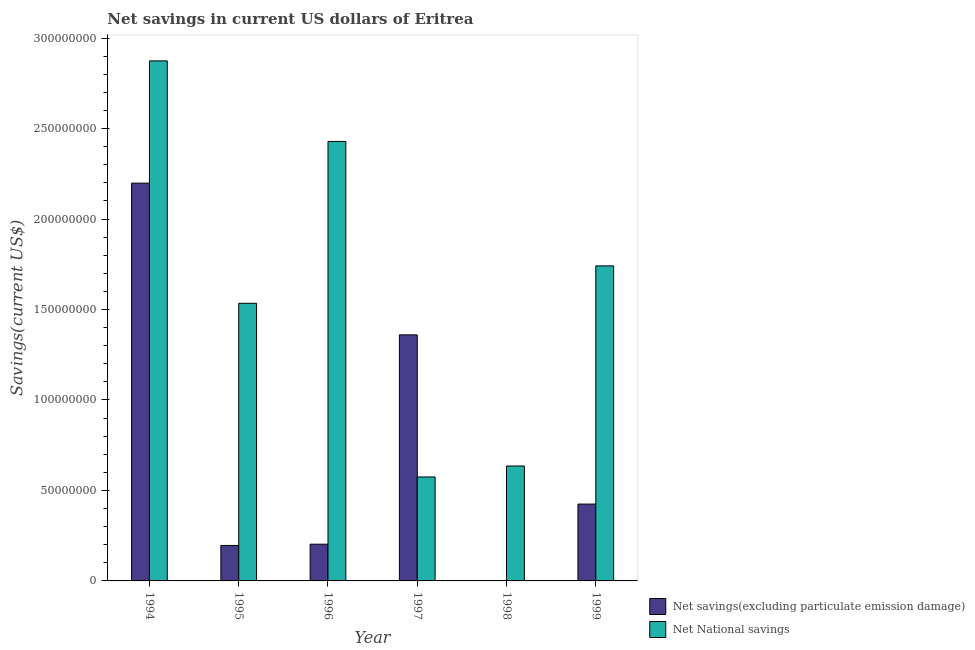How many different coloured bars are there?
Make the answer very short. 2. Are the number of bars per tick equal to the number of legend labels?
Offer a very short reply. No. How many bars are there on the 1st tick from the right?
Offer a very short reply. 2. In how many cases, is the number of bars for a given year not equal to the number of legend labels?
Make the answer very short. 1. What is the net national savings in 1994?
Offer a terse response. 2.87e+08. Across all years, what is the maximum net national savings?
Your answer should be very brief. 2.87e+08. In which year was the net savings(excluding particulate emission damage) maximum?
Your answer should be very brief. 1994. What is the total net national savings in the graph?
Make the answer very short. 9.79e+08. What is the difference between the net national savings in 1996 and that in 1997?
Make the answer very short. 1.85e+08. What is the difference between the net savings(excluding particulate emission damage) in 1997 and the net national savings in 1998?
Provide a short and direct response. 1.36e+08. What is the average net savings(excluding particulate emission damage) per year?
Ensure brevity in your answer.  7.30e+07. In how many years, is the net savings(excluding particulate emission damage) greater than 290000000 US$?
Keep it short and to the point. 0. What is the ratio of the net savings(excluding particulate emission damage) in 1995 to that in 1996?
Ensure brevity in your answer.  0.97. Is the net national savings in 1996 less than that in 1998?
Provide a succinct answer. No. What is the difference between the highest and the second highest net savings(excluding particulate emission damage)?
Your response must be concise. 8.39e+07. What is the difference between the highest and the lowest net national savings?
Provide a short and direct response. 2.30e+08. In how many years, is the net savings(excluding particulate emission damage) greater than the average net savings(excluding particulate emission damage) taken over all years?
Provide a succinct answer. 2. Are all the bars in the graph horizontal?
Ensure brevity in your answer.  No. What is the difference between two consecutive major ticks on the Y-axis?
Give a very brief answer. 5.00e+07. Does the graph contain any zero values?
Provide a short and direct response. Yes. Where does the legend appear in the graph?
Provide a short and direct response. Bottom right. How many legend labels are there?
Provide a succinct answer. 2. How are the legend labels stacked?
Your answer should be compact. Vertical. What is the title of the graph?
Provide a short and direct response. Net savings in current US dollars of Eritrea. What is the label or title of the Y-axis?
Offer a terse response. Savings(current US$). What is the Savings(current US$) of Net savings(excluding particulate emission damage) in 1994?
Give a very brief answer. 2.20e+08. What is the Savings(current US$) of Net National savings in 1994?
Provide a succinct answer. 2.87e+08. What is the Savings(current US$) in Net savings(excluding particulate emission damage) in 1995?
Ensure brevity in your answer.  1.96e+07. What is the Savings(current US$) in Net National savings in 1995?
Make the answer very short. 1.53e+08. What is the Savings(current US$) in Net savings(excluding particulate emission damage) in 1996?
Your response must be concise. 2.03e+07. What is the Savings(current US$) of Net National savings in 1996?
Keep it short and to the point. 2.43e+08. What is the Savings(current US$) in Net savings(excluding particulate emission damage) in 1997?
Provide a succinct answer. 1.36e+08. What is the Savings(current US$) of Net National savings in 1997?
Ensure brevity in your answer.  5.74e+07. What is the Savings(current US$) of Net savings(excluding particulate emission damage) in 1998?
Provide a short and direct response. 0. What is the Savings(current US$) of Net National savings in 1998?
Keep it short and to the point. 6.35e+07. What is the Savings(current US$) in Net savings(excluding particulate emission damage) in 1999?
Offer a terse response. 4.25e+07. What is the Savings(current US$) of Net National savings in 1999?
Give a very brief answer. 1.74e+08. Across all years, what is the maximum Savings(current US$) of Net savings(excluding particulate emission damage)?
Keep it short and to the point. 2.20e+08. Across all years, what is the maximum Savings(current US$) in Net National savings?
Your answer should be compact. 2.87e+08. Across all years, what is the minimum Savings(current US$) in Net National savings?
Your answer should be very brief. 5.74e+07. What is the total Savings(current US$) in Net savings(excluding particulate emission damage) in the graph?
Ensure brevity in your answer.  4.38e+08. What is the total Savings(current US$) in Net National savings in the graph?
Make the answer very short. 9.79e+08. What is the difference between the Savings(current US$) in Net savings(excluding particulate emission damage) in 1994 and that in 1995?
Offer a terse response. 2.00e+08. What is the difference between the Savings(current US$) in Net National savings in 1994 and that in 1995?
Provide a short and direct response. 1.34e+08. What is the difference between the Savings(current US$) in Net savings(excluding particulate emission damage) in 1994 and that in 1996?
Provide a short and direct response. 2.00e+08. What is the difference between the Savings(current US$) in Net National savings in 1994 and that in 1996?
Keep it short and to the point. 4.45e+07. What is the difference between the Savings(current US$) of Net savings(excluding particulate emission damage) in 1994 and that in 1997?
Offer a terse response. 8.39e+07. What is the difference between the Savings(current US$) in Net National savings in 1994 and that in 1997?
Your response must be concise. 2.30e+08. What is the difference between the Savings(current US$) of Net National savings in 1994 and that in 1998?
Provide a short and direct response. 2.24e+08. What is the difference between the Savings(current US$) of Net savings(excluding particulate emission damage) in 1994 and that in 1999?
Make the answer very short. 1.77e+08. What is the difference between the Savings(current US$) of Net National savings in 1994 and that in 1999?
Make the answer very short. 1.13e+08. What is the difference between the Savings(current US$) of Net savings(excluding particulate emission damage) in 1995 and that in 1996?
Provide a succinct answer. -6.87e+05. What is the difference between the Savings(current US$) in Net National savings in 1995 and that in 1996?
Your answer should be very brief. -8.95e+07. What is the difference between the Savings(current US$) of Net savings(excluding particulate emission damage) in 1995 and that in 1997?
Keep it short and to the point. -1.16e+08. What is the difference between the Savings(current US$) in Net National savings in 1995 and that in 1997?
Make the answer very short. 9.60e+07. What is the difference between the Savings(current US$) of Net National savings in 1995 and that in 1998?
Make the answer very short. 8.99e+07. What is the difference between the Savings(current US$) in Net savings(excluding particulate emission damage) in 1995 and that in 1999?
Give a very brief answer. -2.29e+07. What is the difference between the Savings(current US$) of Net National savings in 1995 and that in 1999?
Provide a succinct answer. -2.07e+07. What is the difference between the Savings(current US$) in Net savings(excluding particulate emission damage) in 1996 and that in 1997?
Offer a very short reply. -1.16e+08. What is the difference between the Savings(current US$) in Net National savings in 1996 and that in 1997?
Make the answer very short. 1.85e+08. What is the difference between the Savings(current US$) of Net National savings in 1996 and that in 1998?
Offer a terse response. 1.79e+08. What is the difference between the Savings(current US$) in Net savings(excluding particulate emission damage) in 1996 and that in 1999?
Keep it short and to the point. -2.22e+07. What is the difference between the Savings(current US$) in Net National savings in 1996 and that in 1999?
Your response must be concise. 6.88e+07. What is the difference between the Savings(current US$) of Net National savings in 1997 and that in 1998?
Give a very brief answer. -6.06e+06. What is the difference between the Savings(current US$) of Net savings(excluding particulate emission damage) in 1997 and that in 1999?
Ensure brevity in your answer.  9.35e+07. What is the difference between the Savings(current US$) of Net National savings in 1997 and that in 1999?
Provide a succinct answer. -1.17e+08. What is the difference between the Savings(current US$) in Net National savings in 1998 and that in 1999?
Give a very brief answer. -1.11e+08. What is the difference between the Savings(current US$) in Net savings(excluding particulate emission damage) in 1994 and the Savings(current US$) in Net National savings in 1995?
Your answer should be compact. 6.64e+07. What is the difference between the Savings(current US$) of Net savings(excluding particulate emission damage) in 1994 and the Savings(current US$) of Net National savings in 1996?
Your response must be concise. -2.30e+07. What is the difference between the Savings(current US$) of Net savings(excluding particulate emission damage) in 1994 and the Savings(current US$) of Net National savings in 1997?
Your response must be concise. 1.62e+08. What is the difference between the Savings(current US$) in Net savings(excluding particulate emission damage) in 1994 and the Savings(current US$) in Net National savings in 1998?
Your answer should be compact. 1.56e+08. What is the difference between the Savings(current US$) of Net savings(excluding particulate emission damage) in 1994 and the Savings(current US$) of Net National savings in 1999?
Your answer should be compact. 4.57e+07. What is the difference between the Savings(current US$) in Net savings(excluding particulate emission damage) in 1995 and the Savings(current US$) in Net National savings in 1996?
Keep it short and to the point. -2.23e+08. What is the difference between the Savings(current US$) of Net savings(excluding particulate emission damage) in 1995 and the Savings(current US$) of Net National savings in 1997?
Offer a very short reply. -3.78e+07. What is the difference between the Savings(current US$) in Net savings(excluding particulate emission damage) in 1995 and the Savings(current US$) in Net National savings in 1998?
Your answer should be very brief. -4.39e+07. What is the difference between the Savings(current US$) of Net savings(excluding particulate emission damage) in 1995 and the Savings(current US$) of Net National savings in 1999?
Give a very brief answer. -1.55e+08. What is the difference between the Savings(current US$) in Net savings(excluding particulate emission damage) in 1996 and the Savings(current US$) in Net National savings in 1997?
Ensure brevity in your answer.  -3.72e+07. What is the difference between the Savings(current US$) of Net savings(excluding particulate emission damage) in 1996 and the Savings(current US$) of Net National savings in 1998?
Your response must be concise. -4.32e+07. What is the difference between the Savings(current US$) in Net savings(excluding particulate emission damage) in 1996 and the Savings(current US$) in Net National savings in 1999?
Your response must be concise. -1.54e+08. What is the difference between the Savings(current US$) of Net savings(excluding particulate emission damage) in 1997 and the Savings(current US$) of Net National savings in 1998?
Make the answer very short. 7.25e+07. What is the difference between the Savings(current US$) in Net savings(excluding particulate emission damage) in 1997 and the Savings(current US$) in Net National savings in 1999?
Give a very brief answer. -3.81e+07. What is the average Savings(current US$) of Net savings(excluding particulate emission damage) per year?
Offer a terse response. 7.30e+07. What is the average Savings(current US$) of Net National savings per year?
Make the answer very short. 1.63e+08. In the year 1994, what is the difference between the Savings(current US$) of Net savings(excluding particulate emission damage) and Savings(current US$) of Net National savings?
Your response must be concise. -6.76e+07. In the year 1995, what is the difference between the Savings(current US$) of Net savings(excluding particulate emission damage) and Savings(current US$) of Net National savings?
Provide a succinct answer. -1.34e+08. In the year 1996, what is the difference between the Savings(current US$) in Net savings(excluding particulate emission damage) and Savings(current US$) in Net National savings?
Your response must be concise. -2.23e+08. In the year 1997, what is the difference between the Savings(current US$) of Net savings(excluding particulate emission damage) and Savings(current US$) of Net National savings?
Provide a succinct answer. 7.85e+07. In the year 1999, what is the difference between the Savings(current US$) in Net savings(excluding particulate emission damage) and Savings(current US$) in Net National savings?
Your answer should be compact. -1.32e+08. What is the ratio of the Savings(current US$) of Net savings(excluding particulate emission damage) in 1994 to that in 1995?
Give a very brief answer. 11.21. What is the ratio of the Savings(current US$) in Net National savings in 1994 to that in 1995?
Offer a terse response. 1.87. What is the ratio of the Savings(current US$) of Net savings(excluding particulate emission damage) in 1994 to that in 1996?
Your answer should be compact. 10.83. What is the ratio of the Savings(current US$) in Net National savings in 1994 to that in 1996?
Make the answer very short. 1.18. What is the ratio of the Savings(current US$) of Net savings(excluding particulate emission damage) in 1994 to that in 1997?
Offer a terse response. 1.62. What is the ratio of the Savings(current US$) of Net National savings in 1994 to that in 1997?
Your answer should be very brief. 5. What is the ratio of the Savings(current US$) in Net National savings in 1994 to that in 1998?
Your answer should be compact. 4.53. What is the ratio of the Savings(current US$) of Net savings(excluding particulate emission damage) in 1994 to that in 1999?
Offer a very short reply. 5.18. What is the ratio of the Savings(current US$) in Net National savings in 1994 to that in 1999?
Provide a short and direct response. 1.65. What is the ratio of the Savings(current US$) of Net savings(excluding particulate emission damage) in 1995 to that in 1996?
Ensure brevity in your answer.  0.97. What is the ratio of the Savings(current US$) of Net National savings in 1995 to that in 1996?
Give a very brief answer. 0.63. What is the ratio of the Savings(current US$) in Net savings(excluding particulate emission damage) in 1995 to that in 1997?
Make the answer very short. 0.14. What is the ratio of the Savings(current US$) in Net National savings in 1995 to that in 1997?
Your response must be concise. 2.67. What is the ratio of the Savings(current US$) of Net National savings in 1995 to that in 1998?
Keep it short and to the point. 2.42. What is the ratio of the Savings(current US$) in Net savings(excluding particulate emission damage) in 1995 to that in 1999?
Provide a succinct answer. 0.46. What is the ratio of the Savings(current US$) in Net National savings in 1995 to that in 1999?
Your response must be concise. 0.88. What is the ratio of the Savings(current US$) of Net savings(excluding particulate emission damage) in 1996 to that in 1997?
Keep it short and to the point. 0.15. What is the ratio of the Savings(current US$) of Net National savings in 1996 to that in 1997?
Keep it short and to the point. 4.23. What is the ratio of the Savings(current US$) in Net National savings in 1996 to that in 1998?
Make the answer very short. 3.82. What is the ratio of the Savings(current US$) in Net savings(excluding particulate emission damage) in 1996 to that in 1999?
Make the answer very short. 0.48. What is the ratio of the Savings(current US$) in Net National savings in 1996 to that in 1999?
Ensure brevity in your answer.  1.4. What is the ratio of the Savings(current US$) in Net National savings in 1997 to that in 1998?
Make the answer very short. 0.9. What is the ratio of the Savings(current US$) in Net savings(excluding particulate emission damage) in 1997 to that in 1999?
Your response must be concise. 3.2. What is the ratio of the Savings(current US$) of Net National savings in 1997 to that in 1999?
Provide a succinct answer. 0.33. What is the ratio of the Savings(current US$) of Net National savings in 1998 to that in 1999?
Provide a short and direct response. 0.36. What is the difference between the highest and the second highest Savings(current US$) of Net savings(excluding particulate emission damage)?
Offer a terse response. 8.39e+07. What is the difference between the highest and the second highest Savings(current US$) of Net National savings?
Offer a terse response. 4.45e+07. What is the difference between the highest and the lowest Savings(current US$) of Net savings(excluding particulate emission damage)?
Provide a short and direct response. 2.20e+08. What is the difference between the highest and the lowest Savings(current US$) in Net National savings?
Give a very brief answer. 2.30e+08. 